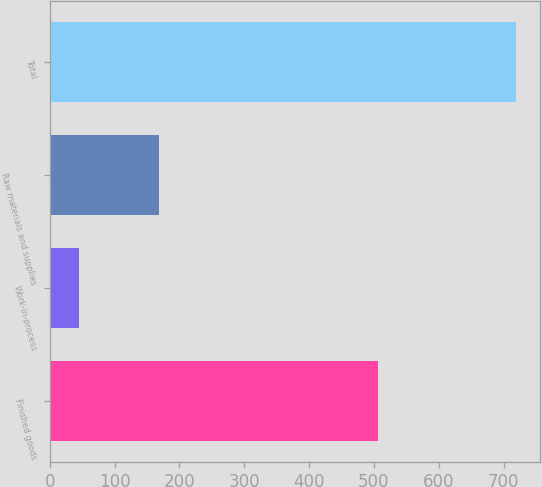Convert chart. <chart><loc_0><loc_0><loc_500><loc_500><bar_chart><fcel>Finished goods<fcel>Work-in-process<fcel>Raw materials and supplies<fcel>Total<nl><fcel>506<fcel>45<fcel>169<fcel>720<nl></chart> 